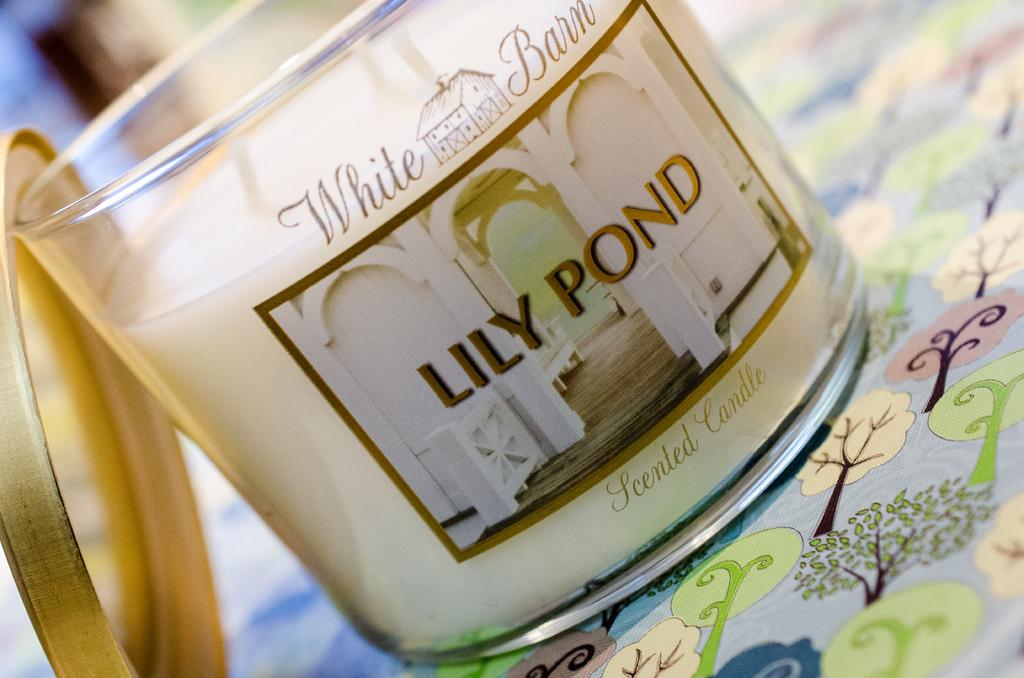<image>
Provide a brief description of the given image. A Lily Pond branded candle has not been lit yet. 